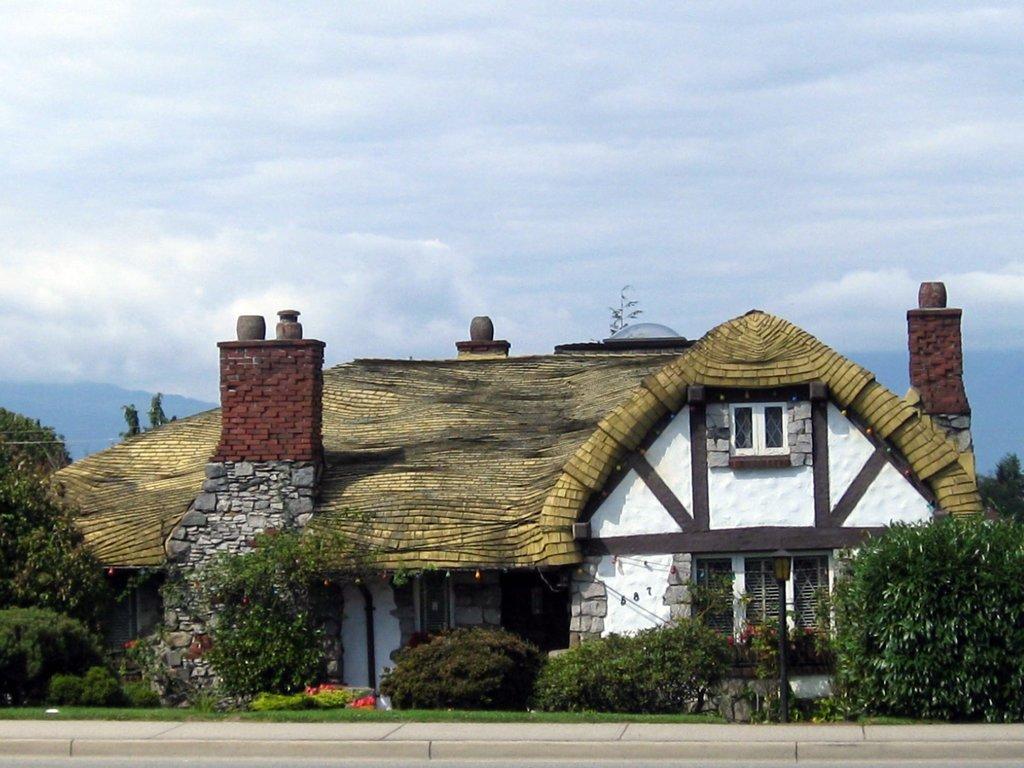In one or two sentences, can you explain what this image depicts? Here in this picture we can see a house with door and windows present over a place and in the front of it we can see plants and trees present and we can see the sky is fully covered with clouds and in the far we can see mountains present. 